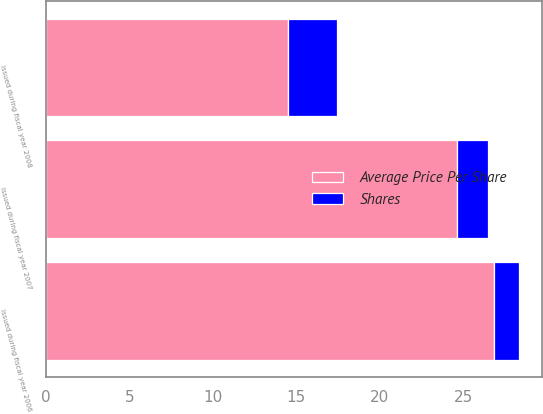Convert chart. <chart><loc_0><loc_0><loc_500><loc_500><stacked_bar_chart><ecel><fcel>Issued during fiscal year 2006<fcel>Issued during fiscal year 2007<fcel>Issued during fiscal year 2008<nl><fcel>Shares<fcel>1.5<fcel>1.9<fcel>2.9<nl><fcel>Average Price Per Share<fcel>26.81<fcel>24.59<fcel>14.52<nl></chart> 